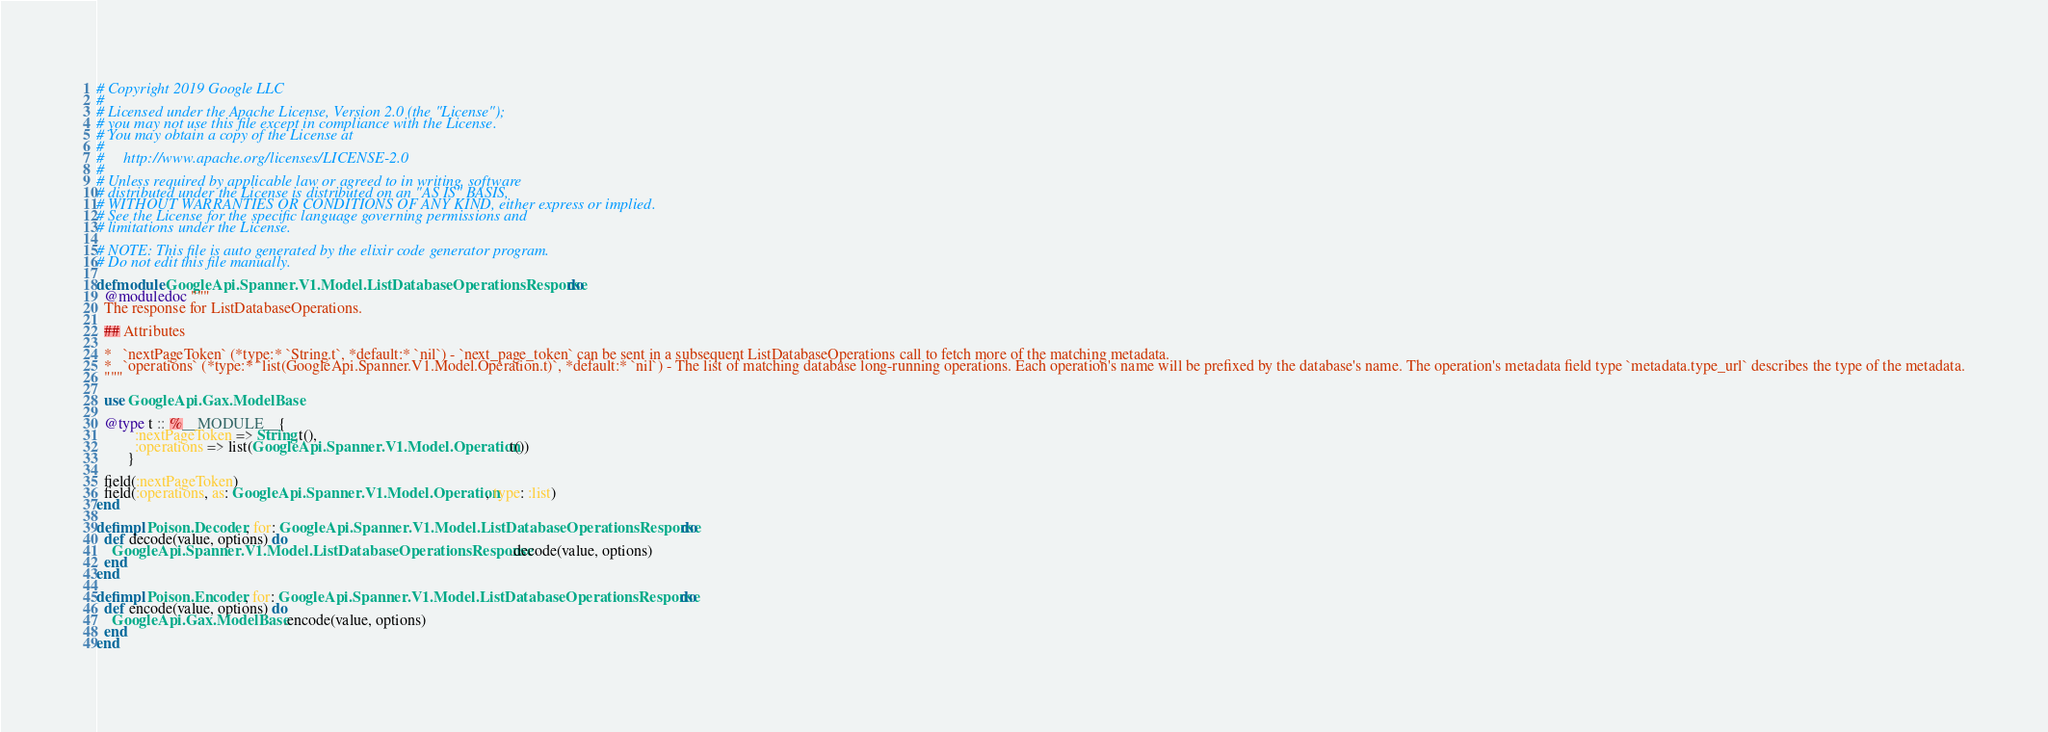Convert code to text. <code><loc_0><loc_0><loc_500><loc_500><_Elixir_># Copyright 2019 Google LLC
#
# Licensed under the Apache License, Version 2.0 (the "License");
# you may not use this file except in compliance with the License.
# You may obtain a copy of the License at
#
#     http://www.apache.org/licenses/LICENSE-2.0
#
# Unless required by applicable law or agreed to in writing, software
# distributed under the License is distributed on an "AS IS" BASIS,
# WITHOUT WARRANTIES OR CONDITIONS OF ANY KIND, either express or implied.
# See the License for the specific language governing permissions and
# limitations under the License.

# NOTE: This file is auto generated by the elixir code generator program.
# Do not edit this file manually.

defmodule GoogleApi.Spanner.V1.Model.ListDatabaseOperationsResponse do
  @moduledoc """
  The response for ListDatabaseOperations.

  ## Attributes

  *   `nextPageToken` (*type:* `String.t`, *default:* `nil`) - `next_page_token` can be sent in a subsequent ListDatabaseOperations call to fetch more of the matching metadata.
  *   `operations` (*type:* `list(GoogleApi.Spanner.V1.Model.Operation.t)`, *default:* `nil`) - The list of matching database long-running operations. Each operation's name will be prefixed by the database's name. The operation's metadata field type `metadata.type_url` describes the type of the metadata.
  """

  use GoogleApi.Gax.ModelBase

  @type t :: %__MODULE__{
          :nextPageToken => String.t(),
          :operations => list(GoogleApi.Spanner.V1.Model.Operation.t())
        }

  field(:nextPageToken)
  field(:operations, as: GoogleApi.Spanner.V1.Model.Operation, type: :list)
end

defimpl Poison.Decoder, for: GoogleApi.Spanner.V1.Model.ListDatabaseOperationsResponse do
  def decode(value, options) do
    GoogleApi.Spanner.V1.Model.ListDatabaseOperationsResponse.decode(value, options)
  end
end

defimpl Poison.Encoder, for: GoogleApi.Spanner.V1.Model.ListDatabaseOperationsResponse do
  def encode(value, options) do
    GoogleApi.Gax.ModelBase.encode(value, options)
  end
end
</code> 